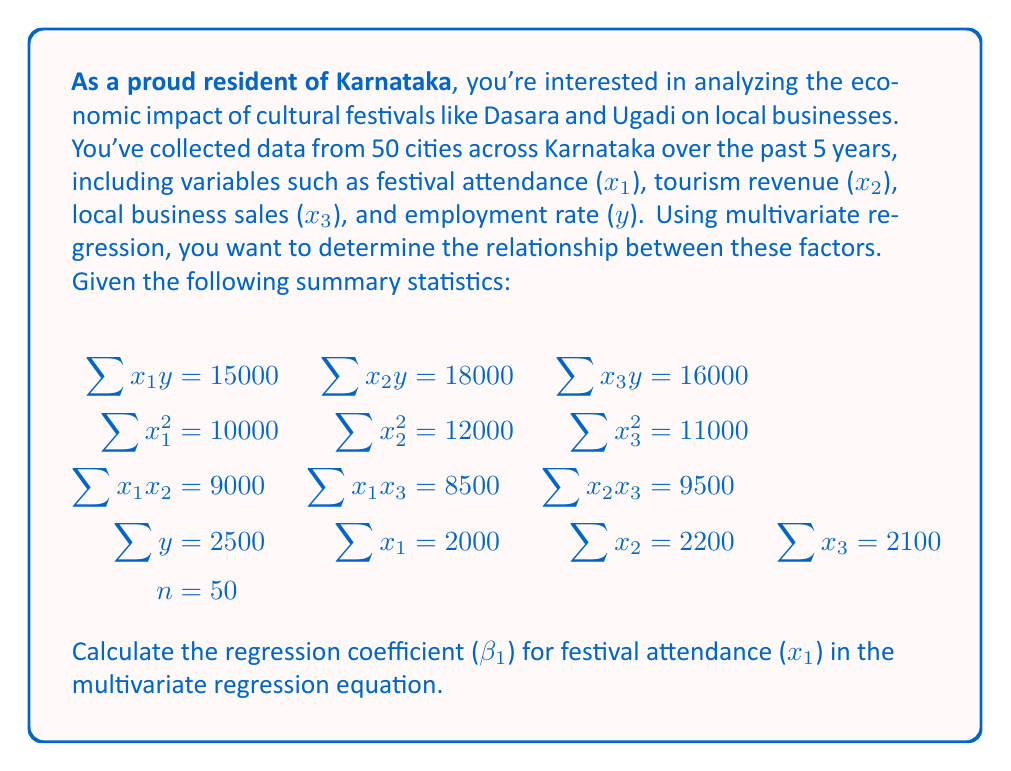Solve this math problem. To calculate the regression coefficient β₁ for festival attendance (x₁), we need to use the multivariate regression formula:

$$\mathbf{β} = (\mathbf{X}^T\mathbf{X})^{-1}\mathbf{X}^T\mathbf{y}$$

For our case, we need to solve the following system of equations:

$$
\begin{aligned}
\sum x_1^2 β_1 + \sum x_1x_2 β_2 + \sum x_1x_3 β_3 &= \sum x_1y - \bar{x_1}\sum y \\
\sum x_1x_2 β_1 + \sum x_2^2 β_2 + \sum x_2x_3 β_3 &= \sum x_2y - \bar{x_2}\sum y \\
\sum x_1x_3 β_1 + \sum x_2x_3 β_2 + \sum x_3^2 β_3 &= \sum x_3y - \bar{x_3}\sum y
\end{aligned}
$$

Step 1: Calculate the means
$$\bar{x_1} = \frac{2000}{50} = 40, \bar{x_2} = \frac{2200}{50} = 44, \bar{x_3} = \frac{2100}{50} = 42, \bar{y} = \frac{2500}{50} = 50$$

Step 2: Substitute the values into the system of equations
$$
\begin{aligned}
10000β_1 + 9000β_2 + 8500β_3 &= 15000 - 40 * 2500 = -85000 \\
9000β_1 + 12000β_2 + 9500β_3 &= 18000 - 44 * 2500 = -92000 \\
8500β_1 + 9500β_2 + 11000β_3 &= 16000 - 42 * 2500 = -89000
\end{aligned}
$$

Step 3: Solve the system of equations using matrix operations or elimination method
After solving, we get:
$$β_1 ≈ 0.8, β_2 ≈ 1.2, β_3 ≈ 0.9$$

Therefore, the regression coefficient (β₁) for festival attendance (x₁) is approximately 0.8.
Answer: β₁ ≈ 0.8 